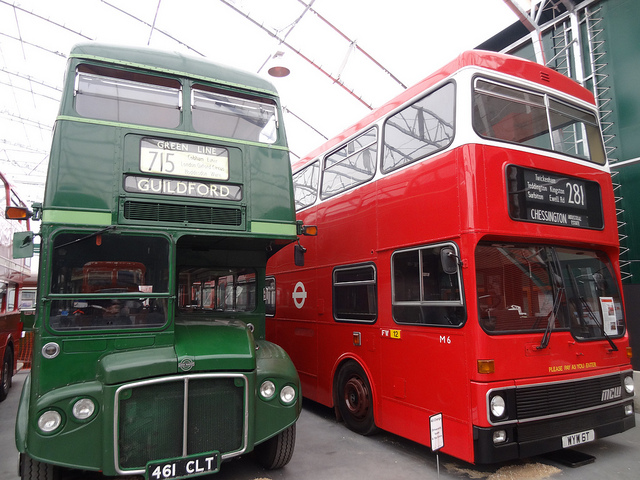Extract all visible text content from this image. GUILDFORD 715 Green LINE 281 CHESSINGTON M6 CLT 461 